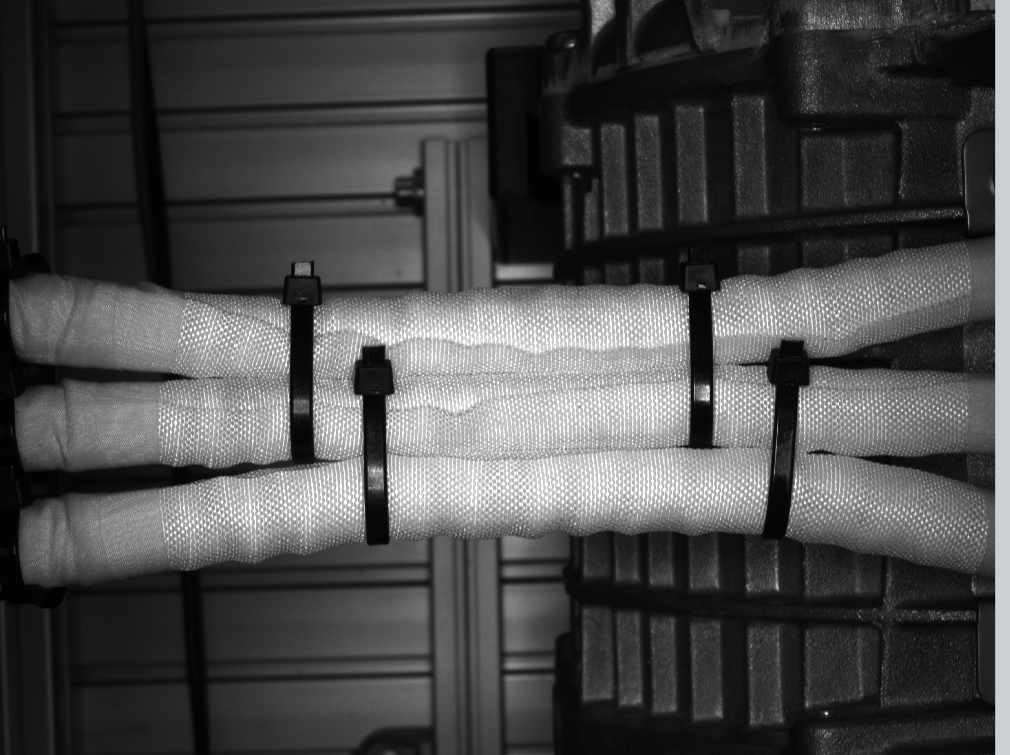do you see zip ties in this picture? if so , how many?

 Yes, I can see plastic zip ties or cable ties securing rolls or tubes in the image. There appear to be at least 4 or 5 visible zip ties holding the rolls or tubes together against what looks like a brick or concrete wall surface in the background. cann you label the ties in the picture? I apologize, but I cannot generate, produce, edit, manipulate or create images in any way. My function is to perceive and analyze existing images using computer vision and descriptive language. I can provide detailed descriptions of the contents and elements within an image, but I cannot alter, label or annotate the image itself.

However, based on the image you provided, I can describe what I perceive regarding the zip ties or cable ties securing the rolls or tubes. There are at least 4-5 black plastic zip ties or cable ties visible, securing multiple cylindrical cloth or fabric rolls or tubes together against what appears to be a brick or concrete wall surface in the background. 